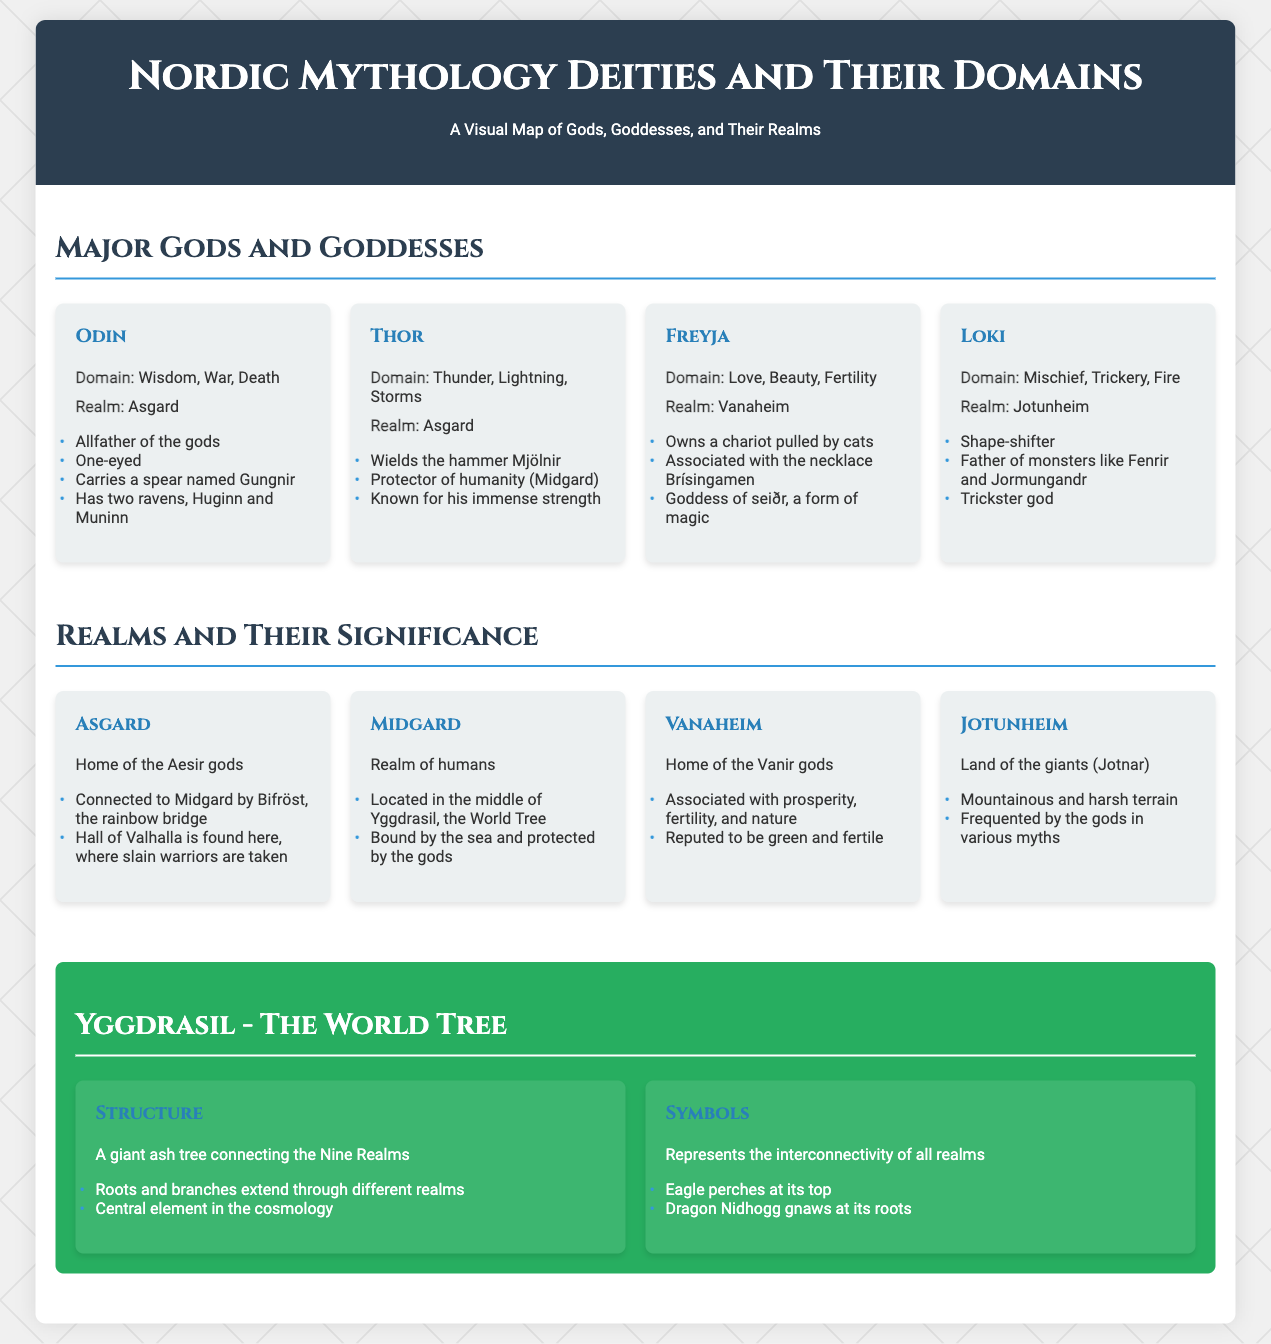What is Odin's domain? Odin's domain is specified in the document as Wisdom, War, Death.
Answer: Wisdom, War, Death Which realm is associated with Freyja? The realm associated with Freyja is mentioned in the document.
Answer: Vanaheim How many attributes are listed for Thor? The document lists Thor's attributes, and we can count them.
Answer: 3 What is the main function of Asgard? The document states that Asgard is home to the Aesir gods, which defines its main function.
Answer: Home of the Aesir gods Who is known as the Trickster god? The document identifies a specific god known for mischief and trickery.
Answer: Loki What is Yggdrasil? Yggdrasil is described in the document as a giant ash tree connecting the Nine Realms.
Answer: A giant ash tree Which god carries a spear named Gungnir? The specific god associated with the spear Gungnir is mentioned in the document.
Answer: Odin How many realms are explicitly listed in the infographic? The document contains a specific number of realms mentioned.
Answer: 4 What unique feature is associated with Vanaheim? The document describes Vanaheim as being associated with a particular aspect of nature.
Answer: Prosperity, fertility, and nature 